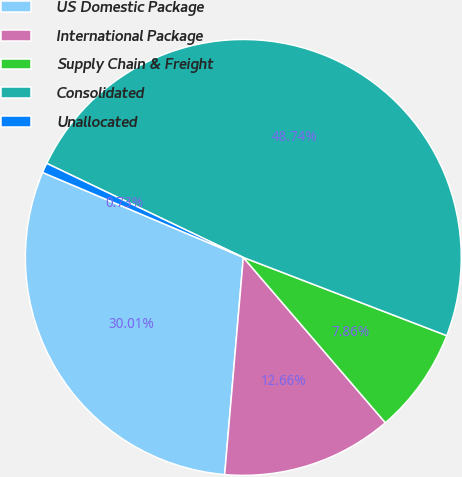<chart> <loc_0><loc_0><loc_500><loc_500><pie_chart><fcel>US Domestic Package<fcel>International Package<fcel>Supply Chain & Freight<fcel>Consolidated<fcel>Unallocated<nl><fcel>30.01%<fcel>12.66%<fcel>7.86%<fcel>48.74%<fcel>0.73%<nl></chart> 